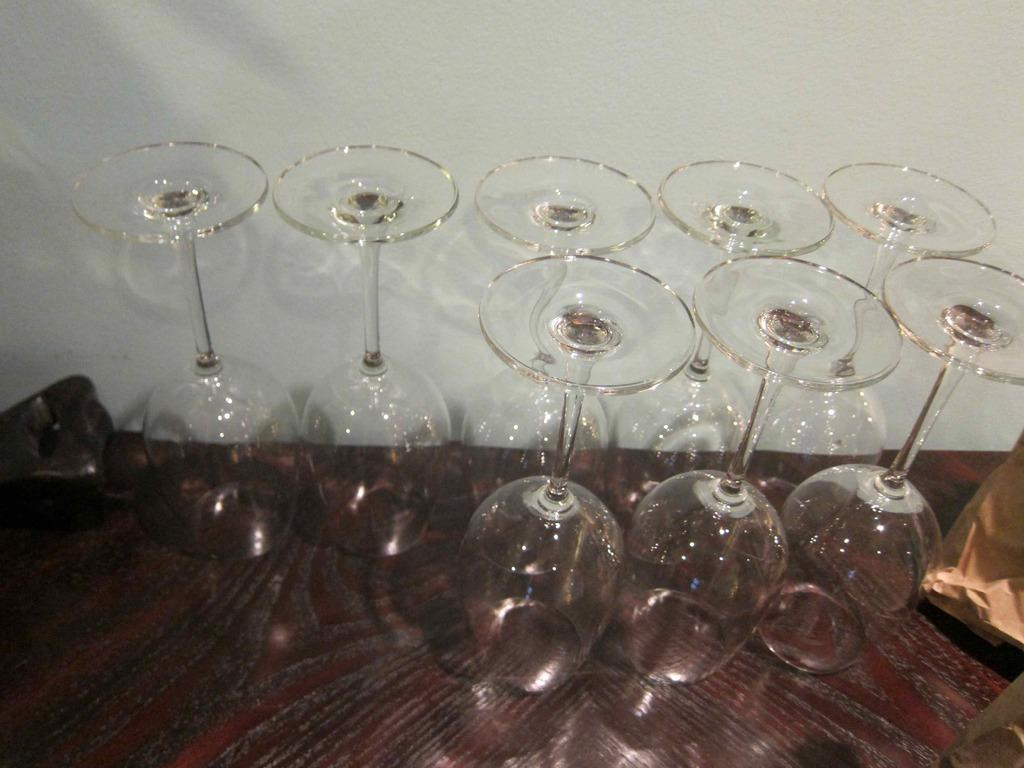What objects are visible in the image? There are glasses in the image. Where are the glasses placed? The glasses are on a wooden platform. What can be seen in the background of the image? There is a wall in the background of the image. How does the goat interact with the glasses in the image? There is no goat present in the image, so it cannot interact with the glasses. 